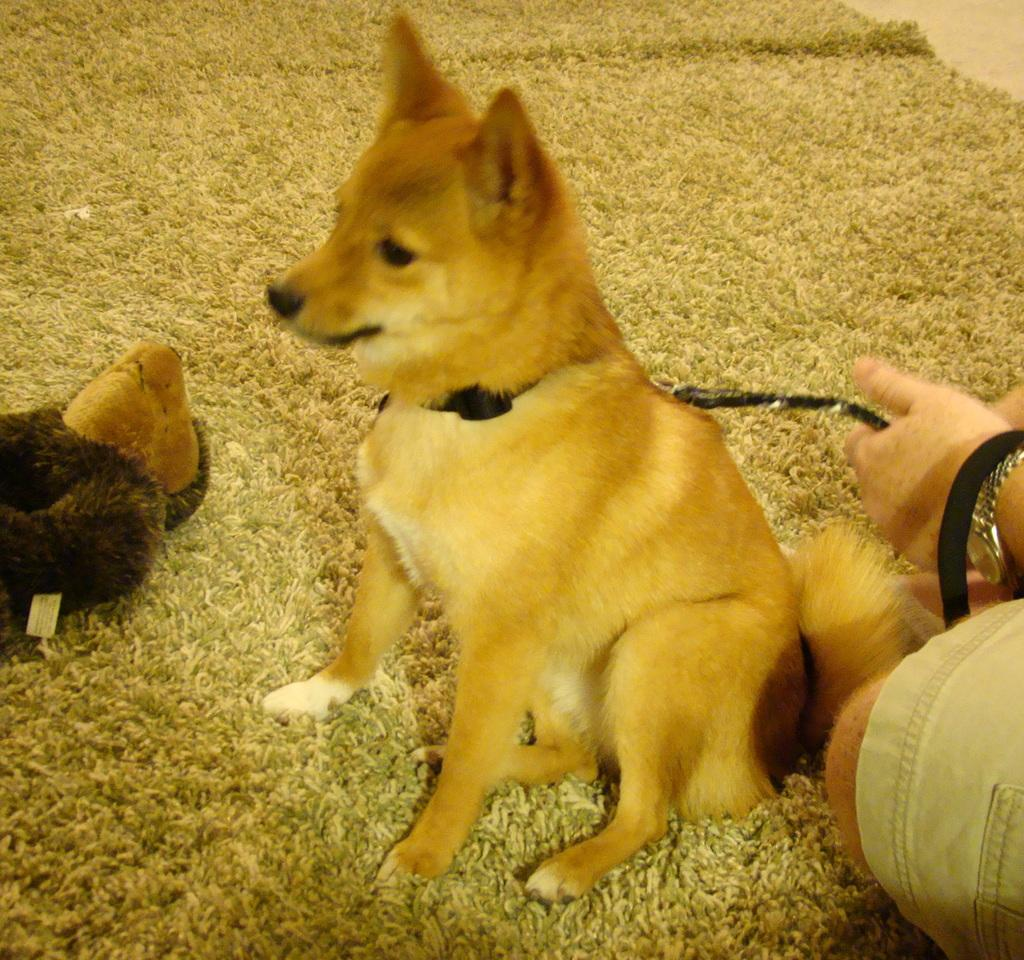What is the dog doing in the image? The dog is sitting on a mat in the image. What can be seen on the left side of the image? There is a toy on the left side of the image. Who is holding the dog in the image? The dog is being held by a person in the image. What accessories is the person wearing? The person is wearing a watch and a belt in the image. What type of building is visible in the background of the image? There is no building visible in the background of the image; it only features the dog, the mat, the toy, and the person holding the dog. 